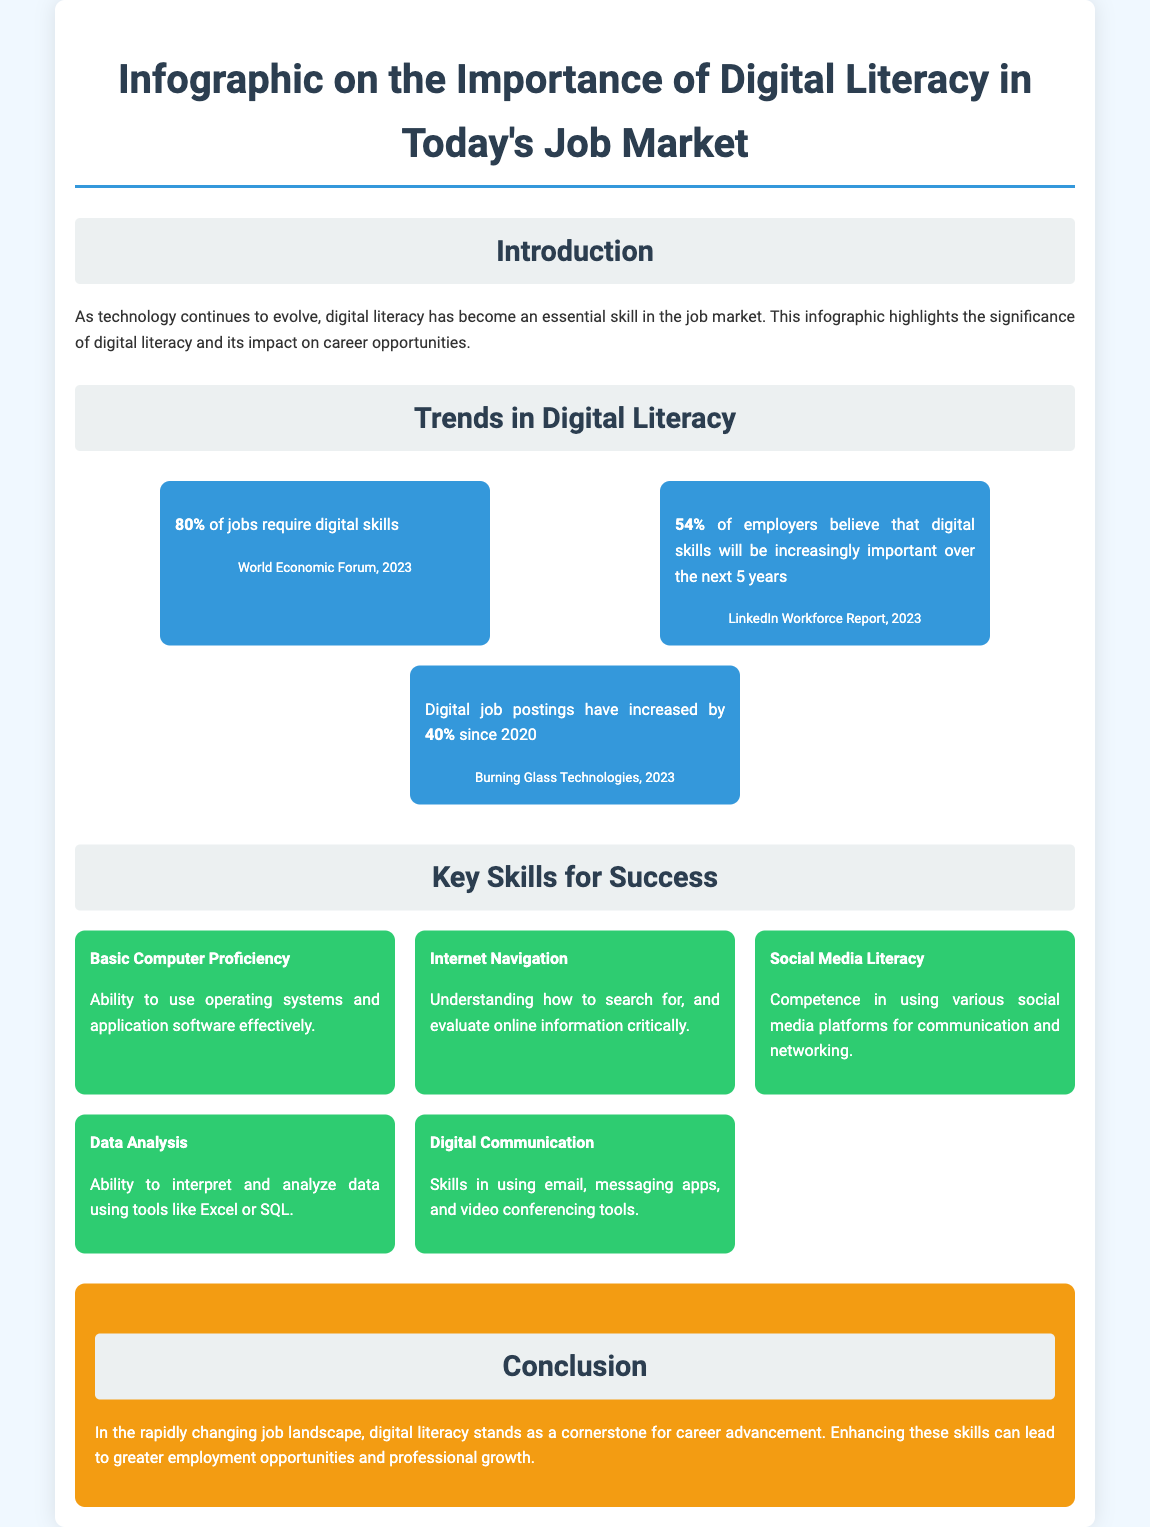What percentage of jobs require digital skills? The document states that 80% of jobs require digital skills.
Answer: 80% What skills are necessary for effective digital communication? The document lists skills in using email, messaging apps, and video conferencing tools for digital communication.
Answer: Digital Communication What is the increase in digital job postings since 2020? According to the document, digital job postings have increased by 40% since 2020.
Answer: 40% Which organization reported that 54% of employers believe digital skills will be increasingly important? The document mentions this statistic is from the LinkedIn Workforce Report, 2023.
Answer: LinkedIn Workforce Report What are the two key skills related to data? The document highlights Data Analysis and Basic Computer Proficiency as key skills related to data.
Answer: Data Analysis, Basic Computer Proficiency What color are the trend items in the infographic? The document specifies that the trend items have a background color of light blue (#3498db).
Answer: Light blue How many key skills for success are listed in the document? The document states there are five key skills listed for success.
Answer: Five What conclusion does the document reach about digital literacy? The document concludes that digital literacy is a cornerstone for career advancement.
Answer: Cornerstone for career advancement 